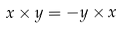Convert formula to latex. <formula><loc_0><loc_0><loc_500><loc_500>x \times y = - y \times x</formula> 